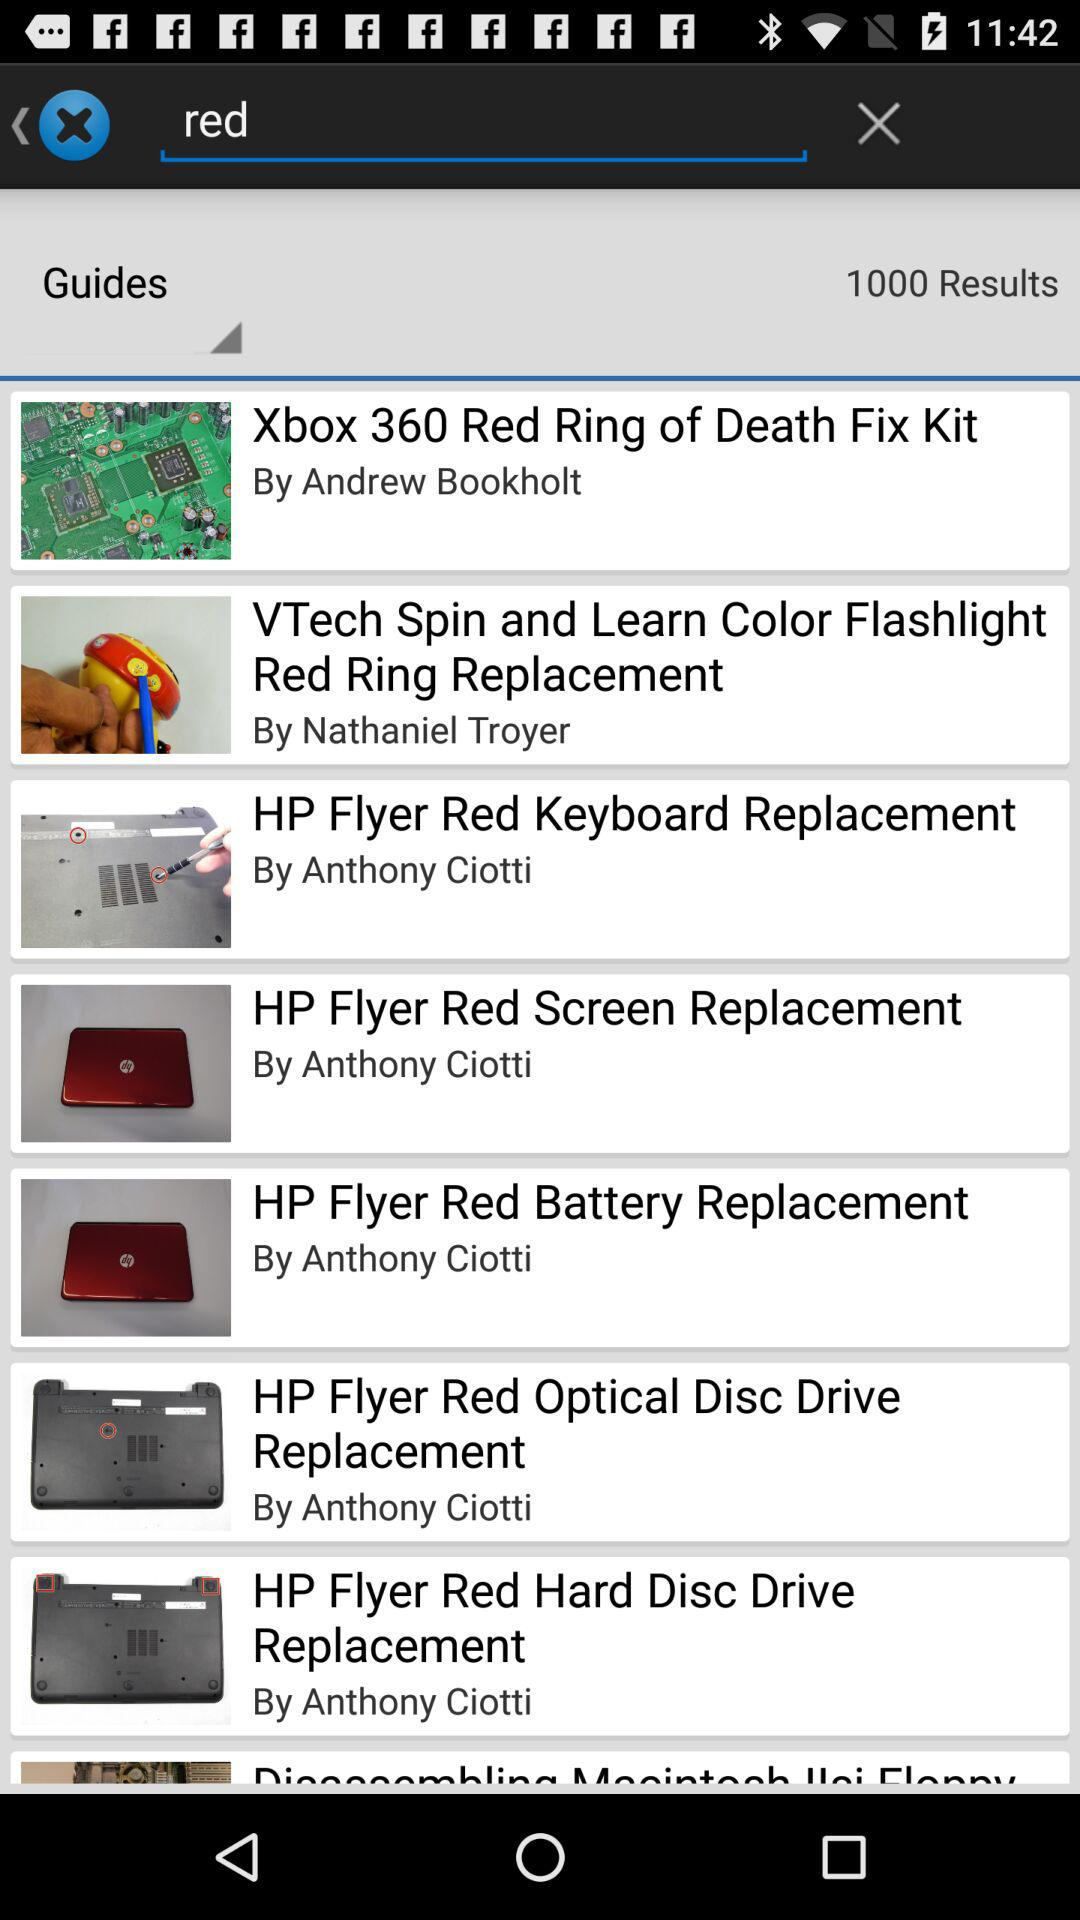What is the total number of results? The total number of results is 1000. 